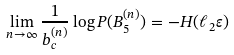<formula> <loc_0><loc_0><loc_500><loc_500>\lim _ { n \to \infty } \frac { 1 } { b _ { c } ^ { ( n ) } } \log P ( B _ { 5 } ^ { ( n ) } ) = - H ( \ell _ { 2 } \varepsilon )</formula> 